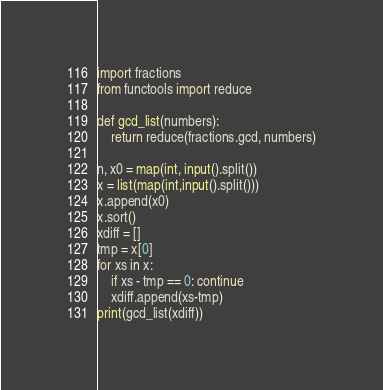Convert code to text. <code><loc_0><loc_0><loc_500><loc_500><_Python_>import fractions
from functools import reduce

def gcd_list(numbers):
    return reduce(fractions.gcd, numbers)

n, x0 = map(int, input().split())
x = list(map(int,input().split()))
x.append(x0)
x.sort()
xdiff = []
tmp = x[0]
for xs in x:
    if xs - tmp == 0: continue
    xdiff.append(xs-tmp)
print(gcd_list(xdiff))</code> 